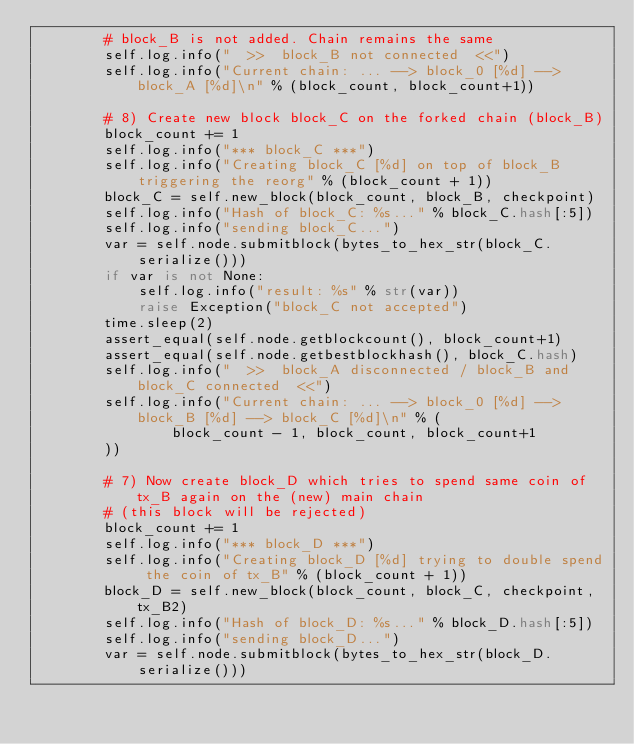Convert code to text. <code><loc_0><loc_0><loc_500><loc_500><_Python_>        # block_B is not added. Chain remains the same
        self.log.info("  >>  block_B not connected  <<")
        self.log.info("Current chain: ... --> block_0 [%d] --> block_A [%d]\n" % (block_count, block_count+1))

        # 8) Create new block block_C on the forked chain (block_B)
        block_count += 1
        self.log.info("*** block_C ***")
        self.log.info("Creating block_C [%d] on top of block_B triggering the reorg" % (block_count + 1))
        block_C = self.new_block(block_count, block_B, checkpoint)
        self.log.info("Hash of block_C: %s..." % block_C.hash[:5])
        self.log.info("sending block_C...")
        var = self.node.submitblock(bytes_to_hex_str(block_C.serialize()))
        if var is not None:
            self.log.info("result: %s" % str(var))
            raise Exception("block_C not accepted")
        time.sleep(2)
        assert_equal(self.node.getblockcount(), block_count+1)
        assert_equal(self.node.getbestblockhash(), block_C.hash)
        self.log.info("  >>  block_A disconnected / block_B and block_C connected  <<")
        self.log.info("Current chain: ... --> block_0 [%d] --> block_B [%d] --> block_C [%d]\n" % (
                block_count - 1, block_count, block_count+1
        ))

        # 7) Now create block_D which tries to spend same coin of tx_B again on the (new) main chain
        # (this block will be rejected)
        block_count += 1
        self.log.info("*** block_D ***")
        self.log.info("Creating block_D [%d] trying to double spend the coin of tx_B" % (block_count + 1))
        block_D = self.new_block(block_count, block_C, checkpoint, tx_B2)
        self.log.info("Hash of block_D: %s..." % block_D.hash[:5])
        self.log.info("sending block_D...")
        var = self.node.submitblock(bytes_to_hex_str(block_D.serialize()))</code> 